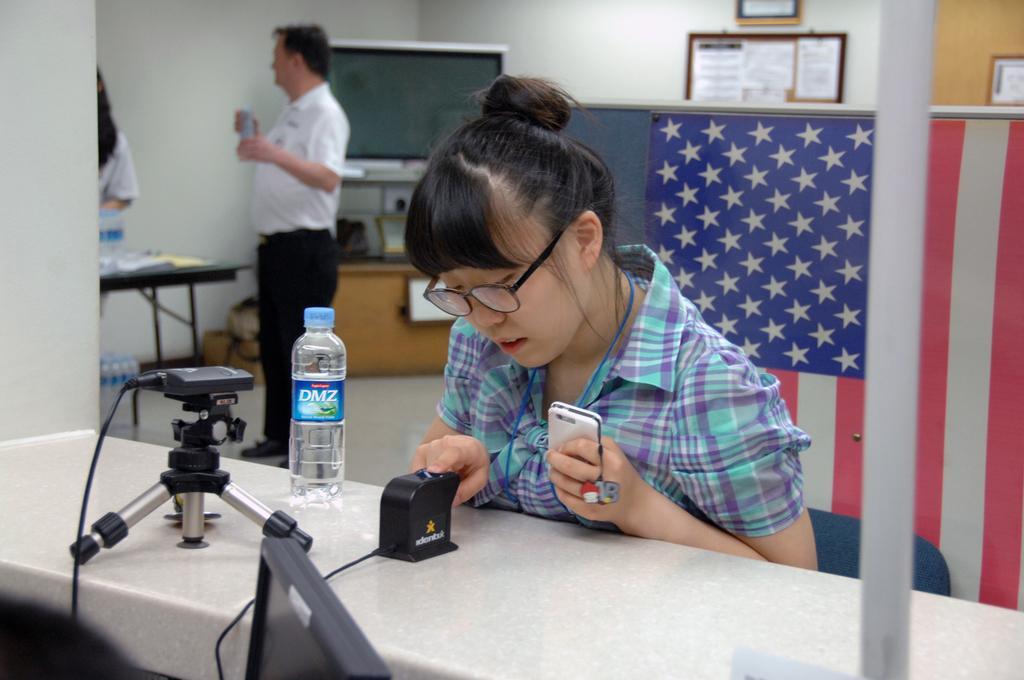How would you summarize this image in a sentence or two? In this image I can see the person sitting and holding the mobile. In front I can see the bottle and few objects on the white color surface. In the background I can see the person standing and few papers attached to the board and the board is attached to the wall and the wall is in white color. 